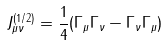Convert formula to latex. <formula><loc_0><loc_0><loc_500><loc_500>J _ { \mu \nu } ^ { ( 1 / 2 ) } = \frac { 1 } { 4 } ( \Gamma _ { \mu } \Gamma _ { \nu } - \Gamma _ { \nu } \Gamma _ { \mu } )</formula> 